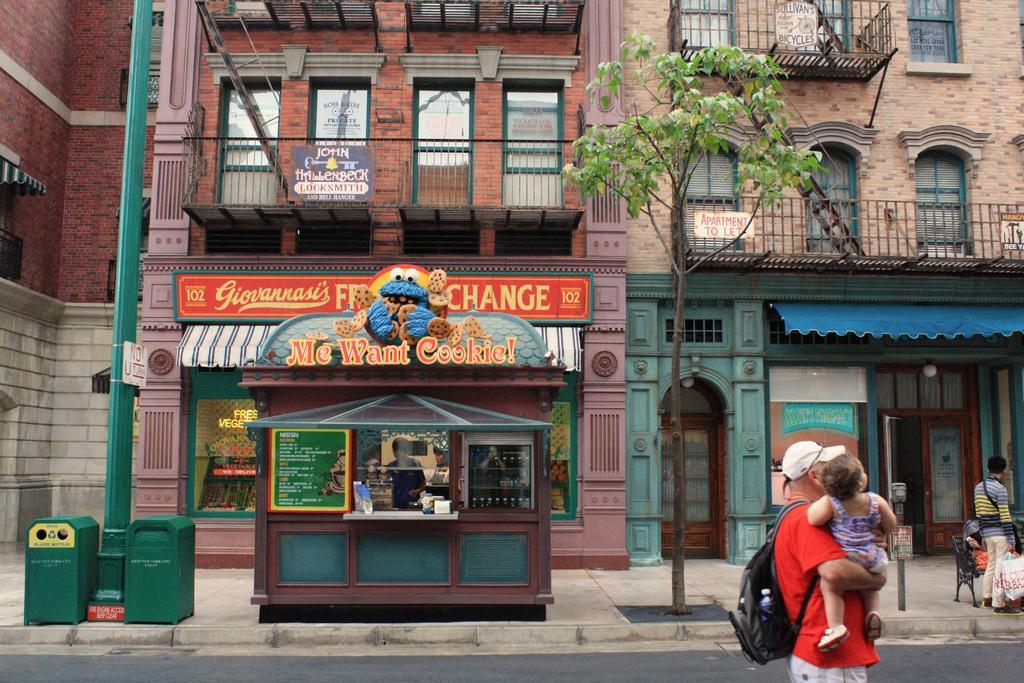How would you summarize this image in a sentence or two? In this picture I can see buildings and a man standing holding bags in his hand and another man standing holding a baby in his hand and he wore a backpack on his back and I can see couple of dustbins and a pole with a sign board and I can see a tree and a cookie store on the sidewalk and I can see a man standing in the store and I can see few boards with text and I can see metal stairs and it looks like a woman seated on the bench. 